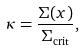<formula> <loc_0><loc_0><loc_500><loc_500>\kappa = \frac { \Sigma ( x ) } { \Sigma _ { { \text {crit} } } } ,</formula> 